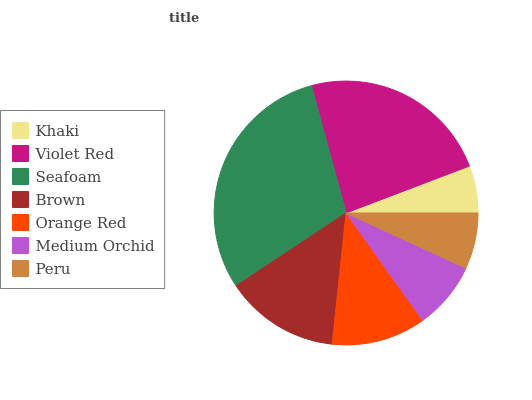Is Khaki the minimum?
Answer yes or no. Yes. Is Seafoam the maximum?
Answer yes or no. Yes. Is Violet Red the minimum?
Answer yes or no. No. Is Violet Red the maximum?
Answer yes or no. No. Is Violet Red greater than Khaki?
Answer yes or no. Yes. Is Khaki less than Violet Red?
Answer yes or no. Yes. Is Khaki greater than Violet Red?
Answer yes or no. No. Is Violet Red less than Khaki?
Answer yes or no. No. Is Orange Red the high median?
Answer yes or no. Yes. Is Orange Red the low median?
Answer yes or no. Yes. Is Khaki the high median?
Answer yes or no. No. Is Brown the low median?
Answer yes or no. No. 